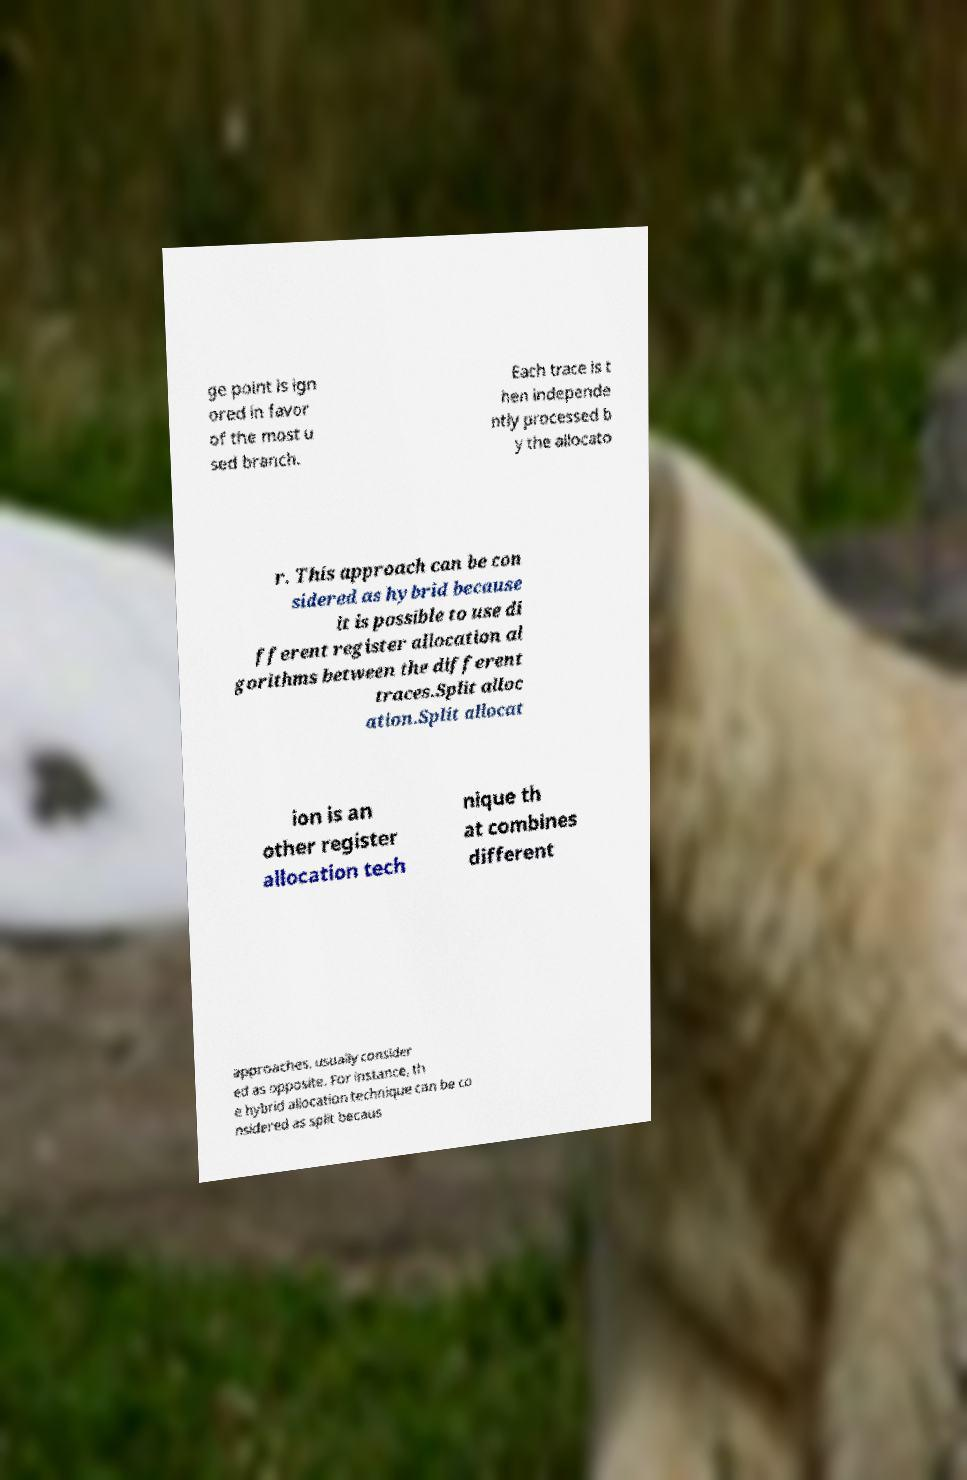I need the written content from this picture converted into text. Can you do that? ge point is ign ored in favor of the most u sed branch. Each trace is t hen independe ntly processed b y the allocato r. This approach can be con sidered as hybrid because it is possible to use di fferent register allocation al gorithms between the different traces.Split alloc ation.Split allocat ion is an other register allocation tech nique th at combines different approaches, usually consider ed as opposite. For instance, th e hybrid allocation technique can be co nsidered as split becaus 